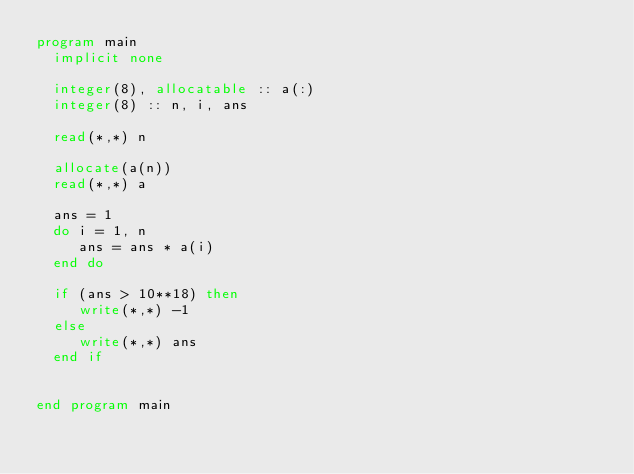Convert code to text. <code><loc_0><loc_0><loc_500><loc_500><_FORTRAN_>program main
  implicit none

  integer(8), allocatable :: a(:)
  integer(8) :: n, i, ans

  read(*,*) n

  allocate(a(n))
  read(*,*) a

  ans = 1
  do i = 1, n
     ans = ans * a(i)
  end do

  if (ans > 10**18) then
     write(*,*) -1
  else
     write(*,*) ans
  end if


end program main


</code> 